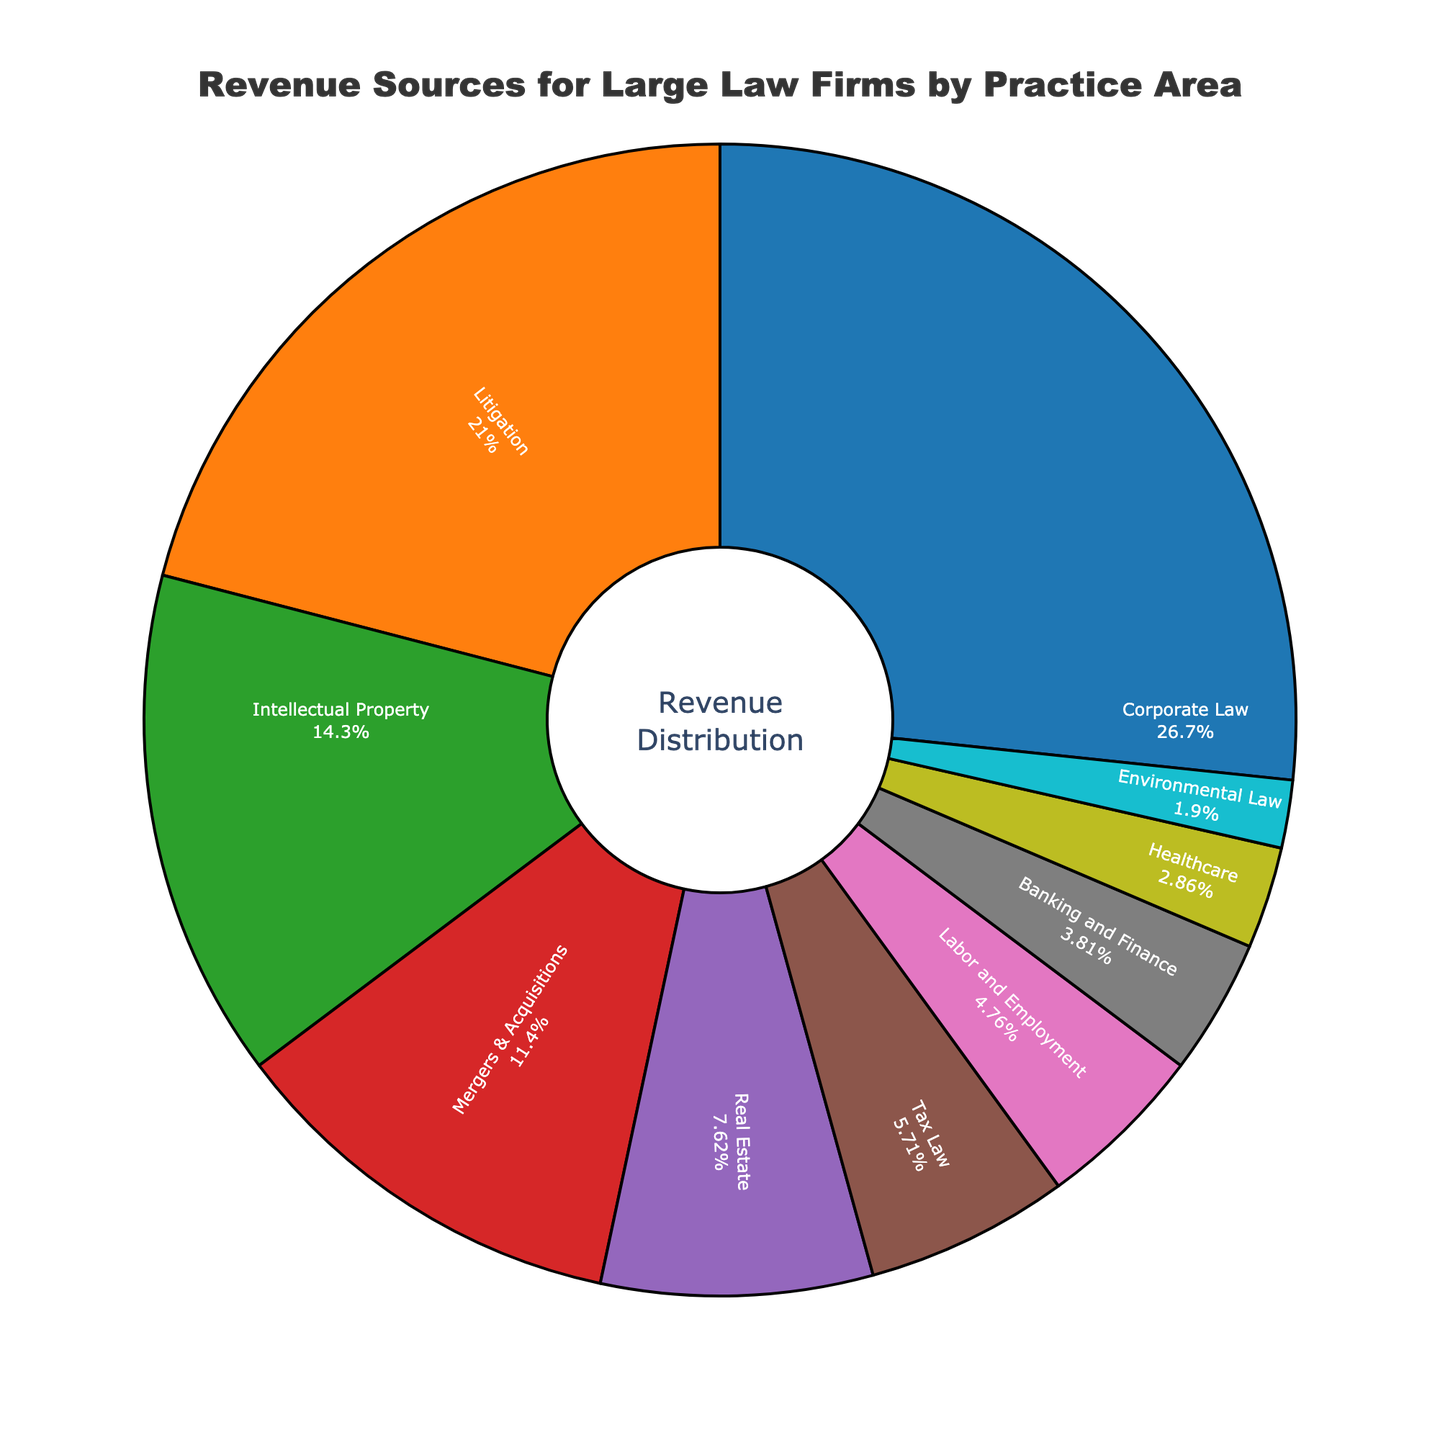Which practice area generates the highest revenue percentage? By examining the largest segment of the pie chart, we can see that Corporate Law occupies the largest portion.
Answer: Corporate Law Which two practice areas combined make up less than 10% of the revenue? By inspecting the pie chart, the smallest segments representing Environmental Law and Healthcare contribute 2% and 3% respectively, adding up to 5%.
Answer: Environmental Law and Healthcare How does the revenue percentage of Litigation compare to Mergers & Acquisitions? The segments for Litigation and Mergers & Acquisitions show 22% and 12% respectively. Therefore, Litigation has a higher percentage compared to Mergers & Acquisitions.
Answer: Litigation is higher What is the total revenue percentage generated by the top three practice areas? Identifying the top three practice areas from the largest segments, we find Corporate Law (28%), Litigation (22%), and Intellectual Property (15%). Summing them yields 28 + 22 + 15 = 65%.
Answer: 65% Describe the color and position of the segment representing Tax Law. The segment for Tax Law is the sixth largest, located between the Real Estate and Labor and Employment segments. It is colored in a distinctive shade (refer to the legend for color correctness).
Answer: Sixth largest, between Real Estate and Labor and Employment Which practice area has closest revenue percentage to Labor and Employment? Labor and Employment contributes 5%. The closest segment in size would be Banking and Finance, which contributes 4%.
Answer: Banking and Finance What is the difference in revenue percentage between Intellectual Property and Real Estate? The pie chart shows Intellectual Property at 15% and Real Estate at 8%. The difference is calculated as 15 - 8 = 7%.
Answer: 7% What practice areas make up exactly 20% of the revenue when combined? Combining segments that add up to 20%, Banking and Finance (4%) and Real Estate (8%) sum to 12%. Adding Labor and Employment (5%) gives us 17%. Finally, including Environmental Law (2%) totals these together as 17 + 2 = 19% (not fitting). Combining Mergers & Acquisitions (12%), Tax Law (6%) sums to 18%. Adding Labor and Employment (5%) overfits. No direct combination gives exact 20%. Therefore:
Answer: No single combination Which practice areas generate less revenue than Intellectual Property? Comparing other segments visually smaller than Intellectual Property's 15% segment includes Mergers & Acquisitions (12%), Real Estate (8%), Tax Law (6%), Labor and Employment (5%), Banking and Finance (4%), Healthcare (3%), and Environmental Law (2%).
Answer: Mergers & Acquisitions, Real Estate, Tax Law, Labor and Employment, Banking and Finance, Healthcare, Environmental Law What is the average revenue percentage of the four smallest practice areas? The pie chart highlights the smallest practice areas as Healthcare (3%), Banking and Finance (4%), Environmental Law (2%), and Labor and Employment (5%). Summing these yields 3 + 4 + 2 + 5 = 14, dividing by four gives us 14/4 = 3.5%.
Answer: 3.5% 